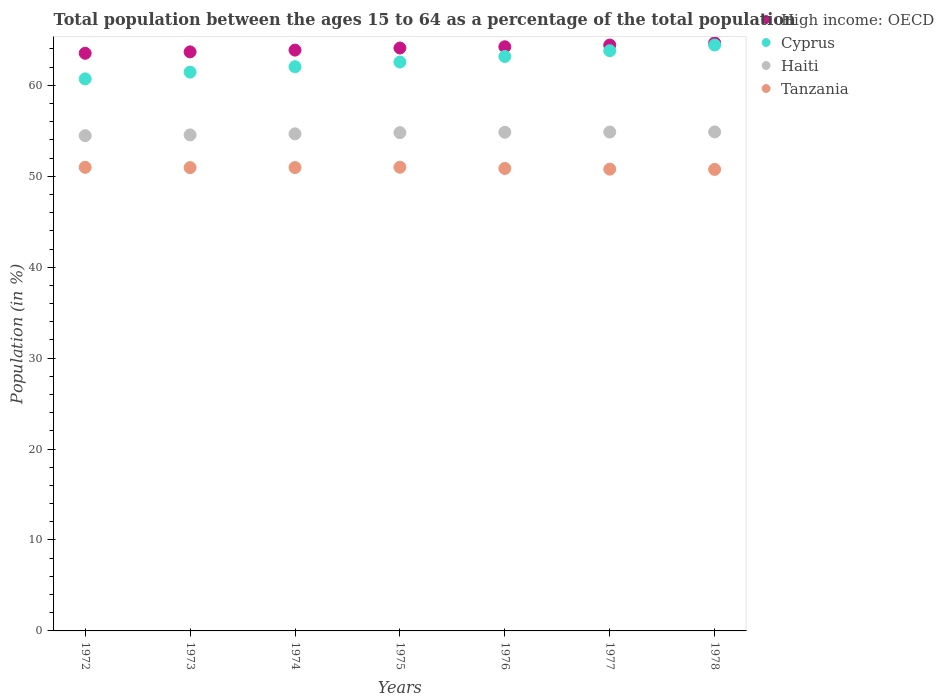How many different coloured dotlines are there?
Offer a terse response. 4. What is the percentage of the population ages 15 to 64 in Tanzania in 1978?
Provide a short and direct response. 50.76. Across all years, what is the maximum percentage of the population ages 15 to 64 in Haiti?
Make the answer very short. 54.88. Across all years, what is the minimum percentage of the population ages 15 to 64 in Haiti?
Provide a succinct answer. 54.47. In which year was the percentage of the population ages 15 to 64 in High income: OECD maximum?
Your answer should be very brief. 1978. What is the total percentage of the population ages 15 to 64 in High income: OECD in the graph?
Offer a terse response. 448.54. What is the difference between the percentage of the population ages 15 to 64 in Cyprus in 1973 and that in 1976?
Your answer should be compact. -1.72. What is the difference between the percentage of the population ages 15 to 64 in Cyprus in 1973 and the percentage of the population ages 15 to 64 in Tanzania in 1976?
Offer a terse response. 10.59. What is the average percentage of the population ages 15 to 64 in Cyprus per year?
Your answer should be compact. 62.6. In the year 1975, what is the difference between the percentage of the population ages 15 to 64 in High income: OECD and percentage of the population ages 15 to 64 in Cyprus?
Your response must be concise. 1.54. What is the ratio of the percentage of the population ages 15 to 64 in Cyprus in 1976 to that in 1977?
Make the answer very short. 0.99. Is the percentage of the population ages 15 to 64 in Cyprus in 1975 less than that in 1978?
Ensure brevity in your answer.  Yes. Is the difference between the percentage of the population ages 15 to 64 in High income: OECD in 1973 and 1978 greater than the difference between the percentage of the population ages 15 to 64 in Cyprus in 1973 and 1978?
Ensure brevity in your answer.  Yes. What is the difference between the highest and the second highest percentage of the population ages 15 to 64 in Haiti?
Make the answer very short. 0.01. What is the difference between the highest and the lowest percentage of the population ages 15 to 64 in Cyprus?
Offer a very short reply. 3.72. In how many years, is the percentage of the population ages 15 to 64 in Tanzania greater than the average percentage of the population ages 15 to 64 in Tanzania taken over all years?
Provide a succinct answer. 4. How many dotlines are there?
Your answer should be very brief. 4. How many years are there in the graph?
Provide a short and direct response. 7. Does the graph contain grids?
Your response must be concise. No. How many legend labels are there?
Offer a very short reply. 4. How are the legend labels stacked?
Offer a terse response. Vertical. What is the title of the graph?
Provide a short and direct response. Total population between the ages 15 to 64 as a percentage of the total population. Does "Micronesia" appear as one of the legend labels in the graph?
Your answer should be very brief. No. What is the label or title of the X-axis?
Offer a terse response. Years. What is the label or title of the Y-axis?
Provide a short and direct response. Population (in %). What is the Population (in %) of High income: OECD in 1972?
Provide a succinct answer. 63.53. What is the Population (in %) of Cyprus in 1972?
Offer a terse response. 60.71. What is the Population (in %) in Haiti in 1972?
Your answer should be very brief. 54.47. What is the Population (in %) of Tanzania in 1972?
Ensure brevity in your answer.  50.99. What is the Population (in %) of High income: OECD in 1973?
Provide a succinct answer. 63.68. What is the Population (in %) in Cyprus in 1973?
Offer a very short reply. 61.46. What is the Population (in %) in Haiti in 1973?
Ensure brevity in your answer.  54.55. What is the Population (in %) in Tanzania in 1973?
Provide a succinct answer. 50.95. What is the Population (in %) of High income: OECD in 1974?
Offer a very short reply. 63.88. What is the Population (in %) in Cyprus in 1974?
Keep it short and to the point. 62.05. What is the Population (in %) in Haiti in 1974?
Your answer should be compact. 54.67. What is the Population (in %) in Tanzania in 1974?
Your response must be concise. 50.96. What is the Population (in %) of High income: OECD in 1975?
Offer a very short reply. 64.11. What is the Population (in %) of Cyprus in 1975?
Make the answer very short. 62.56. What is the Population (in %) of Haiti in 1975?
Keep it short and to the point. 54.8. What is the Population (in %) of Tanzania in 1975?
Provide a succinct answer. 51. What is the Population (in %) of High income: OECD in 1976?
Give a very brief answer. 64.24. What is the Population (in %) of Cyprus in 1976?
Give a very brief answer. 63.18. What is the Population (in %) in Haiti in 1976?
Give a very brief answer. 54.84. What is the Population (in %) of Tanzania in 1976?
Offer a terse response. 50.86. What is the Population (in %) in High income: OECD in 1977?
Provide a short and direct response. 64.44. What is the Population (in %) of Cyprus in 1977?
Offer a terse response. 63.81. What is the Population (in %) in Haiti in 1977?
Your answer should be compact. 54.87. What is the Population (in %) of Tanzania in 1977?
Your answer should be very brief. 50.79. What is the Population (in %) of High income: OECD in 1978?
Make the answer very short. 64.67. What is the Population (in %) of Cyprus in 1978?
Your response must be concise. 64.44. What is the Population (in %) of Haiti in 1978?
Your answer should be very brief. 54.88. What is the Population (in %) in Tanzania in 1978?
Give a very brief answer. 50.76. Across all years, what is the maximum Population (in %) in High income: OECD?
Provide a succinct answer. 64.67. Across all years, what is the maximum Population (in %) of Cyprus?
Offer a very short reply. 64.44. Across all years, what is the maximum Population (in %) of Haiti?
Provide a succinct answer. 54.88. Across all years, what is the maximum Population (in %) in Tanzania?
Keep it short and to the point. 51. Across all years, what is the minimum Population (in %) of High income: OECD?
Your response must be concise. 63.53. Across all years, what is the minimum Population (in %) of Cyprus?
Your answer should be compact. 60.71. Across all years, what is the minimum Population (in %) in Haiti?
Ensure brevity in your answer.  54.47. Across all years, what is the minimum Population (in %) in Tanzania?
Give a very brief answer. 50.76. What is the total Population (in %) in High income: OECD in the graph?
Make the answer very short. 448.54. What is the total Population (in %) of Cyprus in the graph?
Provide a short and direct response. 438.22. What is the total Population (in %) of Haiti in the graph?
Offer a terse response. 383.08. What is the total Population (in %) of Tanzania in the graph?
Give a very brief answer. 356.3. What is the difference between the Population (in %) of High income: OECD in 1972 and that in 1973?
Your answer should be compact. -0.16. What is the difference between the Population (in %) in Cyprus in 1972 and that in 1973?
Your answer should be compact. -0.74. What is the difference between the Population (in %) in Haiti in 1972 and that in 1973?
Your response must be concise. -0.08. What is the difference between the Population (in %) in Tanzania in 1972 and that in 1973?
Make the answer very short. 0.03. What is the difference between the Population (in %) of High income: OECD in 1972 and that in 1974?
Give a very brief answer. -0.35. What is the difference between the Population (in %) of Cyprus in 1972 and that in 1974?
Provide a succinct answer. -1.34. What is the difference between the Population (in %) of Haiti in 1972 and that in 1974?
Offer a terse response. -0.2. What is the difference between the Population (in %) of Tanzania in 1972 and that in 1974?
Provide a succinct answer. 0.03. What is the difference between the Population (in %) of High income: OECD in 1972 and that in 1975?
Offer a terse response. -0.58. What is the difference between the Population (in %) of Cyprus in 1972 and that in 1975?
Ensure brevity in your answer.  -1.85. What is the difference between the Population (in %) in Haiti in 1972 and that in 1975?
Keep it short and to the point. -0.33. What is the difference between the Population (in %) of Tanzania in 1972 and that in 1975?
Your response must be concise. -0.01. What is the difference between the Population (in %) in High income: OECD in 1972 and that in 1976?
Give a very brief answer. -0.72. What is the difference between the Population (in %) of Cyprus in 1972 and that in 1976?
Ensure brevity in your answer.  -2.46. What is the difference between the Population (in %) of Haiti in 1972 and that in 1976?
Your response must be concise. -0.37. What is the difference between the Population (in %) of Tanzania in 1972 and that in 1976?
Keep it short and to the point. 0.13. What is the difference between the Population (in %) in High income: OECD in 1972 and that in 1977?
Give a very brief answer. -0.91. What is the difference between the Population (in %) in Cyprus in 1972 and that in 1977?
Offer a very short reply. -3.1. What is the difference between the Population (in %) in Haiti in 1972 and that in 1977?
Provide a succinct answer. -0.4. What is the difference between the Population (in %) in Tanzania in 1972 and that in 1977?
Your answer should be very brief. 0.2. What is the difference between the Population (in %) of High income: OECD in 1972 and that in 1978?
Provide a succinct answer. -1.14. What is the difference between the Population (in %) in Cyprus in 1972 and that in 1978?
Offer a very short reply. -3.72. What is the difference between the Population (in %) in Haiti in 1972 and that in 1978?
Provide a short and direct response. -0.41. What is the difference between the Population (in %) in Tanzania in 1972 and that in 1978?
Your answer should be very brief. 0.23. What is the difference between the Population (in %) of High income: OECD in 1973 and that in 1974?
Offer a very short reply. -0.19. What is the difference between the Population (in %) in Cyprus in 1973 and that in 1974?
Offer a terse response. -0.6. What is the difference between the Population (in %) in Haiti in 1973 and that in 1974?
Your answer should be compact. -0.12. What is the difference between the Population (in %) in Tanzania in 1973 and that in 1974?
Your response must be concise. -0.01. What is the difference between the Population (in %) of High income: OECD in 1973 and that in 1975?
Ensure brevity in your answer.  -0.42. What is the difference between the Population (in %) in Cyprus in 1973 and that in 1975?
Your answer should be very brief. -1.11. What is the difference between the Population (in %) of Haiti in 1973 and that in 1975?
Provide a succinct answer. -0.25. What is the difference between the Population (in %) in Tanzania in 1973 and that in 1975?
Provide a short and direct response. -0.04. What is the difference between the Population (in %) of High income: OECD in 1973 and that in 1976?
Provide a succinct answer. -0.56. What is the difference between the Population (in %) in Cyprus in 1973 and that in 1976?
Provide a short and direct response. -1.72. What is the difference between the Population (in %) of Haiti in 1973 and that in 1976?
Your response must be concise. -0.29. What is the difference between the Population (in %) of Tanzania in 1973 and that in 1976?
Your answer should be very brief. 0.09. What is the difference between the Population (in %) in High income: OECD in 1973 and that in 1977?
Make the answer very short. -0.75. What is the difference between the Population (in %) of Cyprus in 1973 and that in 1977?
Give a very brief answer. -2.36. What is the difference between the Population (in %) in Haiti in 1973 and that in 1977?
Keep it short and to the point. -0.31. What is the difference between the Population (in %) in Tanzania in 1973 and that in 1977?
Your answer should be very brief. 0.17. What is the difference between the Population (in %) of High income: OECD in 1973 and that in 1978?
Make the answer very short. -0.99. What is the difference between the Population (in %) of Cyprus in 1973 and that in 1978?
Provide a short and direct response. -2.98. What is the difference between the Population (in %) in Haiti in 1973 and that in 1978?
Provide a succinct answer. -0.33. What is the difference between the Population (in %) of Tanzania in 1973 and that in 1978?
Give a very brief answer. 0.2. What is the difference between the Population (in %) of High income: OECD in 1974 and that in 1975?
Make the answer very short. -0.23. What is the difference between the Population (in %) of Cyprus in 1974 and that in 1975?
Your response must be concise. -0.51. What is the difference between the Population (in %) of Haiti in 1974 and that in 1975?
Offer a terse response. -0.13. What is the difference between the Population (in %) of Tanzania in 1974 and that in 1975?
Provide a short and direct response. -0.03. What is the difference between the Population (in %) of High income: OECD in 1974 and that in 1976?
Offer a very short reply. -0.37. What is the difference between the Population (in %) of Cyprus in 1974 and that in 1976?
Give a very brief answer. -1.13. What is the difference between the Population (in %) of Haiti in 1974 and that in 1976?
Offer a very short reply. -0.17. What is the difference between the Population (in %) in Tanzania in 1974 and that in 1976?
Your answer should be compact. 0.1. What is the difference between the Population (in %) in High income: OECD in 1974 and that in 1977?
Offer a terse response. -0.56. What is the difference between the Population (in %) in Cyprus in 1974 and that in 1977?
Your answer should be compact. -1.76. What is the difference between the Population (in %) of Haiti in 1974 and that in 1977?
Your response must be concise. -0.2. What is the difference between the Population (in %) of Tanzania in 1974 and that in 1977?
Give a very brief answer. 0.18. What is the difference between the Population (in %) in High income: OECD in 1974 and that in 1978?
Offer a very short reply. -0.79. What is the difference between the Population (in %) of Cyprus in 1974 and that in 1978?
Give a very brief answer. -2.39. What is the difference between the Population (in %) in Haiti in 1974 and that in 1978?
Provide a succinct answer. -0.21. What is the difference between the Population (in %) in Tanzania in 1974 and that in 1978?
Ensure brevity in your answer.  0.21. What is the difference between the Population (in %) of High income: OECD in 1975 and that in 1976?
Ensure brevity in your answer.  -0.14. What is the difference between the Population (in %) of Cyprus in 1975 and that in 1976?
Offer a very short reply. -0.61. What is the difference between the Population (in %) of Haiti in 1975 and that in 1976?
Make the answer very short. -0.04. What is the difference between the Population (in %) of Tanzania in 1975 and that in 1976?
Provide a succinct answer. 0.13. What is the difference between the Population (in %) of High income: OECD in 1975 and that in 1977?
Ensure brevity in your answer.  -0.33. What is the difference between the Population (in %) of Cyprus in 1975 and that in 1977?
Your response must be concise. -1.25. What is the difference between the Population (in %) in Haiti in 1975 and that in 1977?
Your answer should be compact. -0.07. What is the difference between the Population (in %) in Tanzania in 1975 and that in 1977?
Your response must be concise. 0.21. What is the difference between the Population (in %) in High income: OECD in 1975 and that in 1978?
Provide a succinct answer. -0.56. What is the difference between the Population (in %) in Cyprus in 1975 and that in 1978?
Your answer should be very brief. -1.87. What is the difference between the Population (in %) in Haiti in 1975 and that in 1978?
Make the answer very short. -0.08. What is the difference between the Population (in %) of Tanzania in 1975 and that in 1978?
Offer a terse response. 0.24. What is the difference between the Population (in %) of High income: OECD in 1976 and that in 1977?
Offer a terse response. -0.19. What is the difference between the Population (in %) of Cyprus in 1976 and that in 1977?
Give a very brief answer. -0.63. What is the difference between the Population (in %) in Haiti in 1976 and that in 1977?
Make the answer very short. -0.02. What is the difference between the Population (in %) in Tanzania in 1976 and that in 1977?
Provide a succinct answer. 0.08. What is the difference between the Population (in %) of High income: OECD in 1976 and that in 1978?
Make the answer very short. -0.43. What is the difference between the Population (in %) in Cyprus in 1976 and that in 1978?
Offer a terse response. -1.26. What is the difference between the Population (in %) of Haiti in 1976 and that in 1978?
Ensure brevity in your answer.  -0.04. What is the difference between the Population (in %) of Tanzania in 1976 and that in 1978?
Your answer should be compact. 0.11. What is the difference between the Population (in %) in High income: OECD in 1977 and that in 1978?
Offer a very short reply. -0.23. What is the difference between the Population (in %) in Cyprus in 1977 and that in 1978?
Provide a short and direct response. -0.63. What is the difference between the Population (in %) of Haiti in 1977 and that in 1978?
Offer a very short reply. -0.01. What is the difference between the Population (in %) in Tanzania in 1977 and that in 1978?
Make the answer very short. 0.03. What is the difference between the Population (in %) in High income: OECD in 1972 and the Population (in %) in Cyprus in 1973?
Offer a very short reply. 2.07. What is the difference between the Population (in %) of High income: OECD in 1972 and the Population (in %) of Haiti in 1973?
Make the answer very short. 8.98. What is the difference between the Population (in %) of High income: OECD in 1972 and the Population (in %) of Tanzania in 1973?
Your answer should be compact. 12.57. What is the difference between the Population (in %) of Cyprus in 1972 and the Population (in %) of Haiti in 1973?
Your answer should be compact. 6.16. What is the difference between the Population (in %) in Cyprus in 1972 and the Population (in %) in Tanzania in 1973?
Offer a very short reply. 9.76. What is the difference between the Population (in %) in Haiti in 1972 and the Population (in %) in Tanzania in 1973?
Offer a terse response. 3.52. What is the difference between the Population (in %) in High income: OECD in 1972 and the Population (in %) in Cyprus in 1974?
Your answer should be very brief. 1.48. What is the difference between the Population (in %) in High income: OECD in 1972 and the Population (in %) in Haiti in 1974?
Keep it short and to the point. 8.86. What is the difference between the Population (in %) in High income: OECD in 1972 and the Population (in %) in Tanzania in 1974?
Your response must be concise. 12.57. What is the difference between the Population (in %) in Cyprus in 1972 and the Population (in %) in Haiti in 1974?
Ensure brevity in your answer.  6.05. What is the difference between the Population (in %) in Cyprus in 1972 and the Population (in %) in Tanzania in 1974?
Give a very brief answer. 9.75. What is the difference between the Population (in %) in Haiti in 1972 and the Population (in %) in Tanzania in 1974?
Keep it short and to the point. 3.51. What is the difference between the Population (in %) in High income: OECD in 1972 and the Population (in %) in Cyprus in 1975?
Provide a succinct answer. 0.96. What is the difference between the Population (in %) of High income: OECD in 1972 and the Population (in %) of Haiti in 1975?
Ensure brevity in your answer.  8.73. What is the difference between the Population (in %) of High income: OECD in 1972 and the Population (in %) of Tanzania in 1975?
Provide a short and direct response. 12.53. What is the difference between the Population (in %) of Cyprus in 1972 and the Population (in %) of Haiti in 1975?
Your response must be concise. 5.91. What is the difference between the Population (in %) of Cyprus in 1972 and the Population (in %) of Tanzania in 1975?
Give a very brief answer. 9.72. What is the difference between the Population (in %) in Haiti in 1972 and the Population (in %) in Tanzania in 1975?
Make the answer very short. 3.48. What is the difference between the Population (in %) in High income: OECD in 1972 and the Population (in %) in Cyprus in 1976?
Provide a succinct answer. 0.35. What is the difference between the Population (in %) of High income: OECD in 1972 and the Population (in %) of Haiti in 1976?
Give a very brief answer. 8.69. What is the difference between the Population (in %) of High income: OECD in 1972 and the Population (in %) of Tanzania in 1976?
Your answer should be very brief. 12.67. What is the difference between the Population (in %) of Cyprus in 1972 and the Population (in %) of Haiti in 1976?
Offer a very short reply. 5.87. What is the difference between the Population (in %) in Cyprus in 1972 and the Population (in %) in Tanzania in 1976?
Make the answer very short. 9.85. What is the difference between the Population (in %) in Haiti in 1972 and the Population (in %) in Tanzania in 1976?
Offer a very short reply. 3.61. What is the difference between the Population (in %) in High income: OECD in 1972 and the Population (in %) in Cyprus in 1977?
Your answer should be compact. -0.28. What is the difference between the Population (in %) of High income: OECD in 1972 and the Population (in %) of Haiti in 1977?
Make the answer very short. 8.66. What is the difference between the Population (in %) in High income: OECD in 1972 and the Population (in %) in Tanzania in 1977?
Your response must be concise. 12.74. What is the difference between the Population (in %) of Cyprus in 1972 and the Population (in %) of Haiti in 1977?
Make the answer very short. 5.85. What is the difference between the Population (in %) of Cyprus in 1972 and the Population (in %) of Tanzania in 1977?
Provide a short and direct response. 9.93. What is the difference between the Population (in %) of Haiti in 1972 and the Population (in %) of Tanzania in 1977?
Offer a terse response. 3.69. What is the difference between the Population (in %) in High income: OECD in 1972 and the Population (in %) in Cyprus in 1978?
Keep it short and to the point. -0.91. What is the difference between the Population (in %) of High income: OECD in 1972 and the Population (in %) of Haiti in 1978?
Give a very brief answer. 8.65. What is the difference between the Population (in %) of High income: OECD in 1972 and the Population (in %) of Tanzania in 1978?
Offer a terse response. 12.77. What is the difference between the Population (in %) in Cyprus in 1972 and the Population (in %) in Haiti in 1978?
Make the answer very short. 5.84. What is the difference between the Population (in %) of Cyprus in 1972 and the Population (in %) of Tanzania in 1978?
Offer a very short reply. 9.96. What is the difference between the Population (in %) of Haiti in 1972 and the Population (in %) of Tanzania in 1978?
Your response must be concise. 3.72. What is the difference between the Population (in %) in High income: OECD in 1973 and the Population (in %) in Cyprus in 1974?
Provide a succinct answer. 1.63. What is the difference between the Population (in %) of High income: OECD in 1973 and the Population (in %) of Haiti in 1974?
Offer a very short reply. 9.02. What is the difference between the Population (in %) in High income: OECD in 1973 and the Population (in %) in Tanzania in 1974?
Your answer should be compact. 12.72. What is the difference between the Population (in %) in Cyprus in 1973 and the Population (in %) in Haiti in 1974?
Your response must be concise. 6.79. What is the difference between the Population (in %) in Cyprus in 1973 and the Population (in %) in Tanzania in 1974?
Offer a terse response. 10.49. What is the difference between the Population (in %) of Haiti in 1973 and the Population (in %) of Tanzania in 1974?
Offer a terse response. 3.59. What is the difference between the Population (in %) in High income: OECD in 1973 and the Population (in %) in Cyprus in 1975?
Make the answer very short. 1.12. What is the difference between the Population (in %) in High income: OECD in 1973 and the Population (in %) in Haiti in 1975?
Ensure brevity in your answer.  8.88. What is the difference between the Population (in %) of High income: OECD in 1973 and the Population (in %) of Tanzania in 1975?
Your answer should be compact. 12.69. What is the difference between the Population (in %) of Cyprus in 1973 and the Population (in %) of Haiti in 1975?
Your answer should be very brief. 6.65. What is the difference between the Population (in %) in Cyprus in 1973 and the Population (in %) in Tanzania in 1975?
Keep it short and to the point. 10.46. What is the difference between the Population (in %) of Haiti in 1973 and the Population (in %) of Tanzania in 1975?
Give a very brief answer. 3.56. What is the difference between the Population (in %) in High income: OECD in 1973 and the Population (in %) in Cyprus in 1976?
Keep it short and to the point. 0.51. What is the difference between the Population (in %) of High income: OECD in 1973 and the Population (in %) of Haiti in 1976?
Your answer should be very brief. 8.84. What is the difference between the Population (in %) in High income: OECD in 1973 and the Population (in %) in Tanzania in 1976?
Ensure brevity in your answer.  12.82. What is the difference between the Population (in %) of Cyprus in 1973 and the Population (in %) of Haiti in 1976?
Your answer should be very brief. 6.61. What is the difference between the Population (in %) of Cyprus in 1973 and the Population (in %) of Tanzania in 1976?
Keep it short and to the point. 10.59. What is the difference between the Population (in %) of Haiti in 1973 and the Population (in %) of Tanzania in 1976?
Provide a succinct answer. 3.69. What is the difference between the Population (in %) in High income: OECD in 1973 and the Population (in %) in Cyprus in 1977?
Provide a short and direct response. -0.13. What is the difference between the Population (in %) in High income: OECD in 1973 and the Population (in %) in Haiti in 1977?
Offer a terse response. 8.82. What is the difference between the Population (in %) of High income: OECD in 1973 and the Population (in %) of Tanzania in 1977?
Ensure brevity in your answer.  12.9. What is the difference between the Population (in %) of Cyprus in 1973 and the Population (in %) of Haiti in 1977?
Keep it short and to the point. 6.59. What is the difference between the Population (in %) in Cyprus in 1973 and the Population (in %) in Tanzania in 1977?
Give a very brief answer. 10.67. What is the difference between the Population (in %) in Haiti in 1973 and the Population (in %) in Tanzania in 1977?
Offer a terse response. 3.77. What is the difference between the Population (in %) in High income: OECD in 1973 and the Population (in %) in Cyprus in 1978?
Make the answer very short. -0.75. What is the difference between the Population (in %) of High income: OECD in 1973 and the Population (in %) of Haiti in 1978?
Ensure brevity in your answer.  8.8. What is the difference between the Population (in %) in High income: OECD in 1973 and the Population (in %) in Tanzania in 1978?
Your answer should be very brief. 12.93. What is the difference between the Population (in %) in Cyprus in 1973 and the Population (in %) in Haiti in 1978?
Keep it short and to the point. 6.58. What is the difference between the Population (in %) in Cyprus in 1973 and the Population (in %) in Tanzania in 1978?
Ensure brevity in your answer.  10.7. What is the difference between the Population (in %) in Haiti in 1973 and the Population (in %) in Tanzania in 1978?
Provide a succinct answer. 3.8. What is the difference between the Population (in %) of High income: OECD in 1974 and the Population (in %) of Cyprus in 1975?
Offer a terse response. 1.31. What is the difference between the Population (in %) in High income: OECD in 1974 and the Population (in %) in Haiti in 1975?
Your answer should be compact. 9.08. What is the difference between the Population (in %) of High income: OECD in 1974 and the Population (in %) of Tanzania in 1975?
Your answer should be very brief. 12.88. What is the difference between the Population (in %) in Cyprus in 1974 and the Population (in %) in Haiti in 1975?
Keep it short and to the point. 7.25. What is the difference between the Population (in %) of Cyprus in 1974 and the Population (in %) of Tanzania in 1975?
Your answer should be very brief. 11.06. What is the difference between the Population (in %) of Haiti in 1974 and the Population (in %) of Tanzania in 1975?
Keep it short and to the point. 3.67. What is the difference between the Population (in %) of High income: OECD in 1974 and the Population (in %) of Cyprus in 1976?
Your answer should be very brief. 0.7. What is the difference between the Population (in %) of High income: OECD in 1974 and the Population (in %) of Haiti in 1976?
Ensure brevity in your answer.  9.04. What is the difference between the Population (in %) of High income: OECD in 1974 and the Population (in %) of Tanzania in 1976?
Give a very brief answer. 13.02. What is the difference between the Population (in %) of Cyprus in 1974 and the Population (in %) of Haiti in 1976?
Provide a short and direct response. 7.21. What is the difference between the Population (in %) of Cyprus in 1974 and the Population (in %) of Tanzania in 1976?
Make the answer very short. 11.19. What is the difference between the Population (in %) of Haiti in 1974 and the Population (in %) of Tanzania in 1976?
Provide a succinct answer. 3.81. What is the difference between the Population (in %) of High income: OECD in 1974 and the Population (in %) of Cyprus in 1977?
Provide a short and direct response. 0.06. What is the difference between the Population (in %) in High income: OECD in 1974 and the Population (in %) in Haiti in 1977?
Offer a terse response. 9.01. What is the difference between the Population (in %) of High income: OECD in 1974 and the Population (in %) of Tanzania in 1977?
Provide a succinct answer. 13.09. What is the difference between the Population (in %) in Cyprus in 1974 and the Population (in %) in Haiti in 1977?
Make the answer very short. 7.19. What is the difference between the Population (in %) in Cyprus in 1974 and the Population (in %) in Tanzania in 1977?
Provide a short and direct response. 11.27. What is the difference between the Population (in %) in Haiti in 1974 and the Population (in %) in Tanzania in 1977?
Provide a short and direct response. 3.88. What is the difference between the Population (in %) of High income: OECD in 1974 and the Population (in %) of Cyprus in 1978?
Ensure brevity in your answer.  -0.56. What is the difference between the Population (in %) in High income: OECD in 1974 and the Population (in %) in Haiti in 1978?
Provide a succinct answer. 9. What is the difference between the Population (in %) in High income: OECD in 1974 and the Population (in %) in Tanzania in 1978?
Ensure brevity in your answer.  13.12. What is the difference between the Population (in %) in Cyprus in 1974 and the Population (in %) in Haiti in 1978?
Offer a very short reply. 7.17. What is the difference between the Population (in %) of Cyprus in 1974 and the Population (in %) of Tanzania in 1978?
Offer a very short reply. 11.3. What is the difference between the Population (in %) of Haiti in 1974 and the Population (in %) of Tanzania in 1978?
Offer a terse response. 3.91. What is the difference between the Population (in %) in High income: OECD in 1975 and the Population (in %) in Cyprus in 1976?
Provide a short and direct response. 0.93. What is the difference between the Population (in %) in High income: OECD in 1975 and the Population (in %) in Haiti in 1976?
Your response must be concise. 9.27. What is the difference between the Population (in %) in High income: OECD in 1975 and the Population (in %) in Tanzania in 1976?
Give a very brief answer. 13.25. What is the difference between the Population (in %) in Cyprus in 1975 and the Population (in %) in Haiti in 1976?
Provide a succinct answer. 7.72. What is the difference between the Population (in %) of Cyprus in 1975 and the Population (in %) of Tanzania in 1976?
Keep it short and to the point. 11.7. What is the difference between the Population (in %) in Haiti in 1975 and the Population (in %) in Tanzania in 1976?
Provide a short and direct response. 3.94. What is the difference between the Population (in %) in High income: OECD in 1975 and the Population (in %) in Cyprus in 1977?
Your answer should be very brief. 0.29. What is the difference between the Population (in %) of High income: OECD in 1975 and the Population (in %) of Haiti in 1977?
Offer a very short reply. 9.24. What is the difference between the Population (in %) of High income: OECD in 1975 and the Population (in %) of Tanzania in 1977?
Provide a short and direct response. 13.32. What is the difference between the Population (in %) in Cyprus in 1975 and the Population (in %) in Haiti in 1977?
Make the answer very short. 7.7. What is the difference between the Population (in %) in Cyprus in 1975 and the Population (in %) in Tanzania in 1977?
Your response must be concise. 11.78. What is the difference between the Population (in %) of Haiti in 1975 and the Population (in %) of Tanzania in 1977?
Offer a very short reply. 4.02. What is the difference between the Population (in %) in High income: OECD in 1975 and the Population (in %) in Cyprus in 1978?
Your answer should be very brief. -0.33. What is the difference between the Population (in %) of High income: OECD in 1975 and the Population (in %) of Haiti in 1978?
Your answer should be compact. 9.23. What is the difference between the Population (in %) in High income: OECD in 1975 and the Population (in %) in Tanzania in 1978?
Ensure brevity in your answer.  13.35. What is the difference between the Population (in %) of Cyprus in 1975 and the Population (in %) of Haiti in 1978?
Make the answer very short. 7.69. What is the difference between the Population (in %) in Cyprus in 1975 and the Population (in %) in Tanzania in 1978?
Provide a short and direct response. 11.81. What is the difference between the Population (in %) of Haiti in 1975 and the Population (in %) of Tanzania in 1978?
Your response must be concise. 4.05. What is the difference between the Population (in %) in High income: OECD in 1976 and the Population (in %) in Cyprus in 1977?
Provide a short and direct response. 0.43. What is the difference between the Population (in %) in High income: OECD in 1976 and the Population (in %) in Haiti in 1977?
Provide a short and direct response. 9.38. What is the difference between the Population (in %) of High income: OECD in 1976 and the Population (in %) of Tanzania in 1977?
Keep it short and to the point. 13.46. What is the difference between the Population (in %) of Cyprus in 1976 and the Population (in %) of Haiti in 1977?
Your answer should be compact. 8.31. What is the difference between the Population (in %) of Cyprus in 1976 and the Population (in %) of Tanzania in 1977?
Provide a short and direct response. 12.39. What is the difference between the Population (in %) in Haiti in 1976 and the Population (in %) in Tanzania in 1977?
Ensure brevity in your answer.  4.06. What is the difference between the Population (in %) in High income: OECD in 1976 and the Population (in %) in Cyprus in 1978?
Keep it short and to the point. -0.19. What is the difference between the Population (in %) in High income: OECD in 1976 and the Population (in %) in Haiti in 1978?
Give a very brief answer. 9.37. What is the difference between the Population (in %) of High income: OECD in 1976 and the Population (in %) of Tanzania in 1978?
Your answer should be very brief. 13.49. What is the difference between the Population (in %) of Cyprus in 1976 and the Population (in %) of Haiti in 1978?
Provide a succinct answer. 8.3. What is the difference between the Population (in %) in Cyprus in 1976 and the Population (in %) in Tanzania in 1978?
Give a very brief answer. 12.42. What is the difference between the Population (in %) in Haiti in 1976 and the Population (in %) in Tanzania in 1978?
Give a very brief answer. 4.09. What is the difference between the Population (in %) of High income: OECD in 1977 and the Population (in %) of Cyprus in 1978?
Your answer should be compact. -0. What is the difference between the Population (in %) of High income: OECD in 1977 and the Population (in %) of Haiti in 1978?
Your answer should be compact. 9.56. What is the difference between the Population (in %) in High income: OECD in 1977 and the Population (in %) in Tanzania in 1978?
Your answer should be very brief. 13.68. What is the difference between the Population (in %) in Cyprus in 1977 and the Population (in %) in Haiti in 1978?
Provide a succinct answer. 8.93. What is the difference between the Population (in %) in Cyprus in 1977 and the Population (in %) in Tanzania in 1978?
Give a very brief answer. 13.06. What is the difference between the Population (in %) of Haiti in 1977 and the Population (in %) of Tanzania in 1978?
Offer a terse response. 4.11. What is the average Population (in %) in High income: OECD per year?
Keep it short and to the point. 64.08. What is the average Population (in %) of Cyprus per year?
Your response must be concise. 62.6. What is the average Population (in %) in Haiti per year?
Ensure brevity in your answer.  54.73. What is the average Population (in %) in Tanzania per year?
Ensure brevity in your answer.  50.9. In the year 1972, what is the difference between the Population (in %) of High income: OECD and Population (in %) of Cyprus?
Your response must be concise. 2.81. In the year 1972, what is the difference between the Population (in %) in High income: OECD and Population (in %) in Haiti?
Your response must be concise. 9.06. In the year 1972, what is the difference between the Population (in %) of High income: OECD and Population (in %) of Tanzania?
Offer a terse response. 12.54. In the year 1972, what is the difference between the Population (in %) of Cyprus and Population (in %) of Haiti?
Your answer should be very brief. 6.24. In the year 1972, what is the difference between the Population (in %) in Cyprus and Population (in %) in Tanzania?
Keep it short and to the point. 9.73. In the year 1972, what is the difference between the Population (in %) in Haiti and Population (in %) in Tanzania?
Offer a very short reply. 3.48. In the year 1973, what is the difference between the Population (in %) in High income: OECD and Population (in %) in Cyprus?
Your response must be concise. 2.23. In the year 1973, what is the difference between the Population (in %) of High income: OECD and Population (in %) of Haiti?
Offer a very short reply. 9.13. In the year 1973, what is the difference between the Population (in %) of High income: OECD and Population (in %) of Tanzania?
Your answer should be compact. 12.73. In the year 1973, what is the difference between the Population (in %) in Cyprus and Population (in %) in Haiti?
Make the answer very short. 6.9. In the year 1973, what is the difference between the Population (in %) of Cyprus and Population (in %) of Tanzania?
Your answer should be compact. 10.5. In the year 1973, what is the difference between the Population (in %) in Haiti and Population (in %) in Tanzania?
Provide a short and direct response. 3.6. In the year 1974, what is the difference between the Population (in %) in High income: OECD and Population (in %) in Cyprus?
Give a very brief answer. 1.82. In the year 1974, what is the difference between the Population (in %) of High income: OECD and Population (in %) of Haiti?
Your response must be concise. 9.21. In the year 1974, what is the difference between the Population (in %) in High income: OECD and Population (in %) in Tanzania?
Offer a very short reply. 12.92. In the year 1974, what is the difference between the Population (in %) of Cyprus and Population (in %) of Haiti?
Provide a short and direct response. 7.38. In the year 1974, what is the difference between the Population (in %) of Cyprus and Population (in %) of Tanzania?
Ensure brevity in your answer.  11.09. In the year 1974, what is the difference between the Population (in %) in Haiti and Population (in %) in Tanzania?
Offer a terse response. 3.71. In the year 1975, what is the difference between the Population (in %) of High income: OECD and Population (in %) of Cyprus?
Offer a terse response. 1.54. In the year 1975, what is the difference between the Population (in %) of High income: OECD and Population (in %) of Haiti?
Provide a succinct answer. 9.31. In the year 1975, what is the difference between the Population (in %) in High income: OECD and Population (in %) in Tanzania?
Your answer should be very brief. 13.11. In the year 1975, what is the difference between the Population (in %) in Cyprus and Population (in %) in Haiti?
Provide a short and direct response. 7.76. In the year 1975, what is the difference between the Population (in %) in Cyprus and Population (in %) in Tanzania?
Keep it short and to the point. 11.57. In the year 1975, what is the difference between the Population (in %) in Haiti and Population (in %) in Tanzania?
Provide a succinct answer. 3.81. In the year 1976, what is the difference between the Population (in %) of High income: OECD and Population (in %) of Cyprus?
Your answer should be compact. 1.07. In the year 1976, what is the difference between the Population (in %) of High income: OECD and Population (in %) of Haiti?
Offer a very short reply. 9.4. In the year 1976, what is the difference between the Population (in %) of High income: OECD and Population (in %) of Tanzania?
Offer a very short reply. 13.38. In the year 1976, what is the difference between the Population (in %) in Cyprus and Population (in %) in Haiti?
Provide a succinct answer. 8.34. In the year 1976, what is the difference between the Population (in %) of Cyprus and Population (in %) of Tanzania?
Make the answer very short. 12.32. In the year 1976, what is the difference between the Population (in %) of Haiti and Population (in %) of Tanzania?
Provide a succinct answer. 3.98. In the year 1977, what is the difference between the Population (in %) in High income: OECD and Population (in %) in Cyprus?
Provide a succinct answer. 0.62. In the year 1977, what is the difference between the Population (in %) of High income: OECD and Population (in %) of Haiti?
Keep it short and to the point. 9.57. In the year 1977, what is the difference between the Population (in %) of High income: OECD and Population (in %) of Tanzania?
Provide a short and direct response. 13.65. In the year 1977, what is the difference between the Population (in %) of Cyprus and Population (in %) of Haiti?
Give a very brief answer. 8.95. In the year 1977, what is the difference between the Population (in %) of Cyprus and Population (in %) of Tanzania?
Your answer should be very brief. 13.03. In the year 1977, what is the difference between the Population (in %) in Haiti and Population (in %) in Tanzania?
Your answer should be very brief. 4.08. In the year 1978, what is the difference between the Population (in %) in High income: OECD and Population (in %) in Cyprus?
Provide a short and direct response. 0.23. In the year 1978, what is the difference between the Population (in %) of High income: OECD and Population (in %) of Haiti?
Provide a succinct answer. 9.79. In the year 1978, what is the difference between the Population (in %) in High income: OECD and Population (in %) in Tanzania?
Make the answer very short. 13.91. In the year 1978, what is the difference between the Population (in %) of Cyprus and Population (in %) of Haiti?
Give a very brief answer. 9.56. In the year 1978, what is the difference between the Population (in %) in Cyprus and Population (in %) in Tanzania?
Offer a terse response. 13.68. In the year 1978, what is the difference between the Population (in %) in Haiti and Population (in %) in Tanzania?
Provide a succinct answer. 4.12. What is the ratio of the Population (in %) in High income: OECD in 1972 to that in 1974?
Your answer should be very brief. 0.99. What is the ratio of the Population (in %) of Cyprus in 1972 to that in 1974?
Provide a succinct answer. 0.98. What is the ratio of the Population (in %) in Tanzania in 1972 to that in 1974?
Offer a terse response. 1. What is the ratio of the Population (in %) in High income: OECD in 1972 to that in 1975?
Your answer should be very brief. 0.99. What is the ratio of the Population (in %) in Cyprus in 1972 to that in 1975?
Keep it short and to the point. 0.97. What is the ratio of the Population (in %) in Cyprus in 1972 to that in 1976?
Your response must be concise. 0.96. What is the ratio of the Population (in %) in Haiti in 1972 to that in 1976?
Keep it short and to the point. 0.99. What is the ratio of the Population (in %) in Tanzania in 1972 to that in 1976?
Keep it short and to the point. 1. What is the ratio of the Population (in %) in High income: OECD in 1972 to that in 1977?
Provide a short and direct response. 0.99. What is the ratio of the Population (in %) in Cyprus in 1972 to that in 1977?
Your answer should be very brief. 0.95. What is the ratio of the Population (in %) of Haiti in 1972 to that in 1977?
Provide a short and direct response. 0.99. What is the ratio of the Population (in %) in Tanzania in 1972 to that in 1977?
Your response must be concise. 1. What is the ratio of the Population (in %) of High income: OECD in 1972 to that in 1978?
Offer a terse response. 0.98. What is the ratio of the Population (in %) in Cyprus in 1972 to that in 1978?
Keep it short and to the point. 0.94. What is the ratio of the Population (in %) of Haiti in 1972 to that in 1978?
Offer a terse response. 0.99. What is the ratio of the Population (in %) in Tanzania in 1972 to that in 1978?
Offer a very short reply. 1. What is the ratio of the Population (in %) of High income: OECD in 1973 to that in 1974?
Offer a very short reply. 1. What is the ratio of the Population (in %) in Haiti in 1973 to that in 1974?
Offer a very short reply. 1. What is the ratio of the Population (in %) of Tanzania in 1973 to that in 1974?
Your answer should be compact. 1. What is the ratio of the Population (in %) of High income: OECD in 1973 to that in 1975?
Provide a short and direct response. 0.99. What is the ratio of the Population (in %) of Cyprus in 1973 to that in 1975?
Give a very brief answer. 0.98. What is the ratio of the Population (in %) of Haiti in 1973 to that in 1975?
Offer a terse response. 1. What is the ratio of the Population (in %) of Tanzania in 1973 to that in 1975?
Keep it short and to the point. 1. What is the ratio of the Population (in %) in Cyprus in 1973 to that in 1976?
Your response must be concise. 0.97. What is the ratio of the Population (in %) of Tanzania in 1973 to that in 1976?
Provide a short and direct response. 1. What is the ratio of the Population (in %) in High income: OECD in 1973 to that in 1977?
Offer a very short reply. 0.99. What is the ratio of the Population (in %) of Cyprus in 1973 to that in 1977?
Your answer should be very brief. 0.96. What is the ratio of the Population (in %) in Haiti in 1973 to that in 1977?
Give a very brief answer. 0.99. What is the ratio of the Population (in %) of Tanzania in 1973 to that in 1977?
Keep it short and to the point. 1. What is the ratio of the Population (in %) of High income: OECD in 1973 to that in 1978?
Your response must be concise. 0.98. What is the ratio of the Population (in %) of Cyprus in 1973 to that in 1978?
Provide a short and direct response. 0.95. What is the ratio of the Population (in %) in Cyprus in 1974 to that in 1975?
Make the answer very short. 0.99. What is the ratio of the Population (in %) of Haiti in 1974 to that in 1975?
Offer a terse response. 1. What is the ratio of the Population (in %) of Tanzania in 1974 to that in 1975?
Offer a very short reply. 1. What is the ratio of the Population (in %) of Cyprus in 1974 to that in 1976?
Offer a terse response. 0.98. What is the ratio of the Population (in %) in High income: OECD in 1974 to that in 1977?
Keep it short and to the point. 0.99. What is the ratio of the Population (in %) in Cyprus in 1974 to that in 1977?
Your answer should be compact. 0.97. What is the ratio of the Population (in %) of Haiti in 1974 to that in 1977?
Keep it short and to the point. 1. What is the ratio of the Population (in %) in Tanzania in 1974 to that in 1978?
Give a very brief answer. 1. What is the ratio of the Population (in %) of High income: OECD in 1975 to that in 1976?
Provide a short and direct response. 1. What is the ratio of the Population (in %) of Cyprus in 1975 to that in 1976?
Your answer should be very brief. 0.99. What is the ratio of the Population (in %) in High income: OECD in 1975 to that in 1977?
Offer a very short reply. 0.99. What is the ratio of the Population (in %) of Cyprus in 1975 to that in 1977?
Keep it short and to the point. 0.98. What is the ratio of the Population (in %) of Haiti in 1975 to that in 1977?
Your answer should be very brief. 1. What is the ratio of the Population (in %) of Tanzania in 1975 to that in 1977?
Your response must be concise. 1. What is the ratio of the Population (in %) in High income: OECD in 1975 to that in 1978?
Offer a terse response. 0.99. What is the ratio of the Population (in %) in Cyprus in 1975 to that in 1978?
Your answer should be compact. 0.97. What is the ratio of the Population (in %) of Haiti in 1975 to that in 1978?
Offer a terse response. 1. What is the ratio of the Population (in %) in Tanzania in 1975 to that in 1978?
Ensure brevity in your answer.  1. What is the ratio of the Population (in %) in High income: OECD in 1976 to that in 1977?
Make the answer very short. 1. What is the ratio of the Population (in %) of Tanzania in 1976 to that in 1977?
Give a very brief answer. 1. What is the ratio of the Population (in %) in Cyprus in 1976 to that in 1978?
Ensure brevity in your answer.  0.98. What is the ratio of the Population (in %) of Cyprus in 1977 to that in 1978?
Offer a terse response. 0.99. What is the ratio of the Population (in %) in Haiti in 1977 to that in 1978?
Ensure brevity in your answer.  1. What is the ratio of the Population (in %) in Tanzania in 1977 to that in 1978?
Your answer should be very brief. 1. What is the difference between the highest and the second highest Population (in %) in High income: OECD?
Provide a short and direct response. 0.23. What is the difference between the highest and the second highest Population (in %) in Cyprus?
Ensure brevity in your answer.  0.63. What is the difference between the highest and the second highest Population (in %) of Haiti?
Offer a very short reply. 0.01. What is the difference between the highest and the second highest Population (in %) of Tanzania?
Make the answer very short. 0.01. What is the difference between the highest and the lowest Population (in %) in High income: OECD?
Ensure brevity in your answer.  1.14. What is the difference between the highest and the lowest Population (in %) of Cyprus?
Provide a succinct answer. 3.72. What is the difference between the highest and the lowest Population (in %) in Haiti?
Your answer should be very brief. 0.41. What is the difference between the highest and the lowest Population (in %) of Tanzania?
Give a very brief answer. 0.24. 